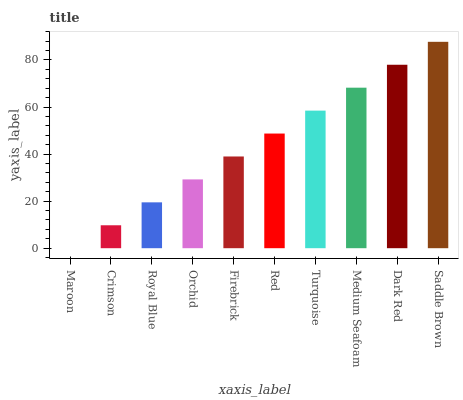Is Maroon the minimum?
Answer yes or no. Yes. Is Saddle Brown the maximum?
Answer yes or no. Yes. Is Crimson the minimum?
Answer yes or no. No. Is Crimson the maximum?
Answer yes or no. No. Is Crimson greater than Maroon?
Answer yes or no. Yes. Is Maroon less than Crimson?
Answer yes or no. Yes. Is Maroon greater than Crimson?
Answer yes or no. No. Is Crimson less than Maroon?
Answer yes or no. No. Is Red the high median?
Answer yes or no. Yes. Is Firebrick the low median?
Answer yes or no. Yes. Is Medium Seafoam the high median?
Answer yes or no. No. Is Crimson the low median?
Answer yes or no. No. 